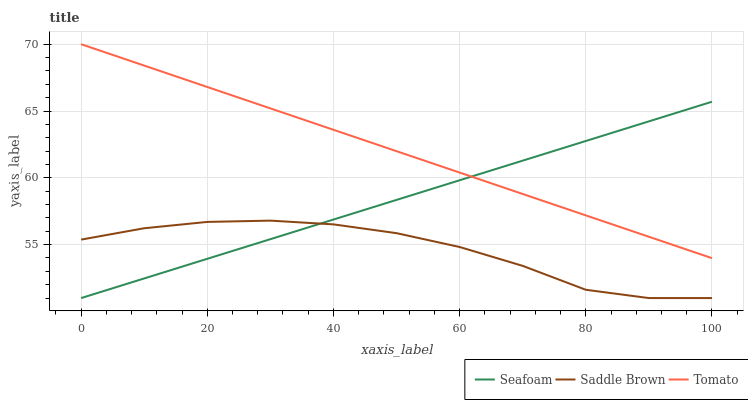Does Seafoam have the minimum area under the curve?
Answer yes or no. No. Does Seafoam have the maximum area under the curve?
Answer yes or no. No. Is Seafoam the smoothest?
Answer yes or no. No. Is Seafoam the roughest?
Answer yes or no. No. Does Seafoam have the highest value?
Answer yes or no. No. Is Saddle Brown less than Tomato?
Answer yes or no. Yes. Is Tomato greater than Saddle Brown?
Answer yes or no. Yes. Does Saddle Brown intersect Tomato?
Answer yes or no. No. 